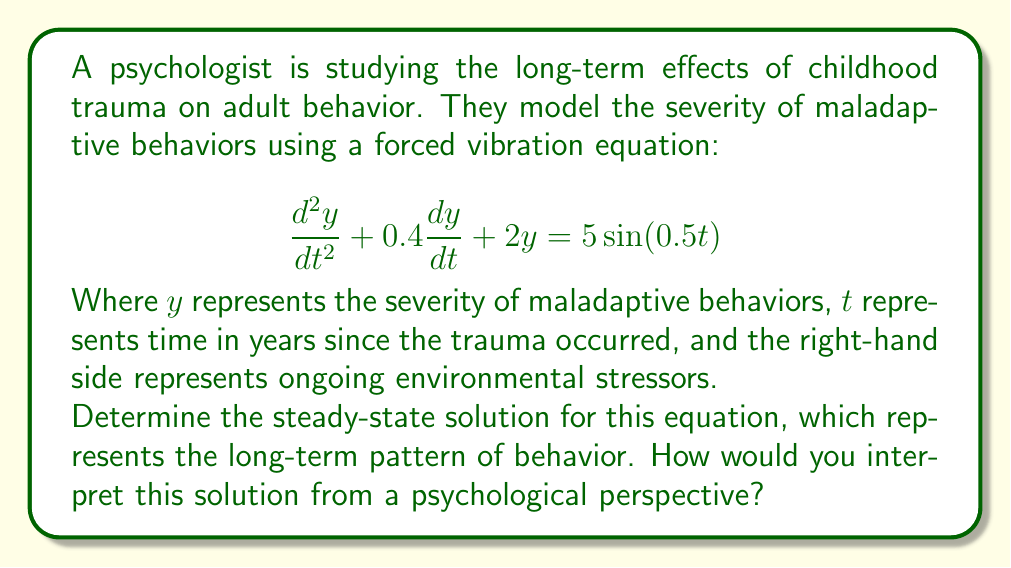Provide a solution to this math problem. To solve this problem, we follow these steps:

1) The general form of a forced vibration equation is:
   $$\frac{d^2y}{dt^2} + 2\zeta\omega_n\frac{dy}{dt} + \omega_n^2y = F_0\sin(\omega t)$$

2) Comparing our equation to this form, we can identify:
   $2\zeta\omega_n = 0.4$
   $\omega_n^2 = 2$
   $F_0 = 5$
   $\omega = 0.5$

3) The steady-state solution for a forced vibration equation has the form:
   $$y_{ss}(t) = A\sin(\omega t) + B\cos(\omega t)$$

4) The amplitudes A and B are given by:
   $$A = \frac{F_0(\omega_n^2 - \omega^2)}{(\omega_n^2 - \omega^2)^2 + (2\zeta\omega_n\omega)^2}$$
   $$B = \frac{F_0(2\zeta\omega_n\omega)}{(\omega_n^2 - \omega^2)^2 + (2\zeta\omega_n\omega)^2}$$

5) Substituting our values:
   $$A = \frac{5(2 - 0.5^2)}{(2 - 0.5^2)^2 + (0.4 \cdot 0.5)^2} \approx 2.4969$$
   $$B = \frac{5(0.4 \cdot 0.5)}{(2 - 0.5^2)^2 + (0.4 \cdot 0.5)^2} \approx 0.2497$$

6) Therefore, the steady-state solution is:
   $$y_{ss}(t) \approx 2.4969\sin(0.5t) + 0.2497\cos(0.5t)$$

From a psychological perspective, this solution suggests that the severity of maladaptive behaviors will fluctuate over time in a sinusoidal pattern. The amplitude of these fluctuations (about 2.5) indicates the range of severity. The presence of both sine and cosine terms suggests a phase shift, meaning the peak severity may not align directly with environmental stressors. The relatively small damping term (0.4) implies that these behaviors persist over time without quickly diminishing, which aligns with the understanding that childhood trauma can have long-lasting effects into adulthood.
Answer: $$y_{ss}(t) \approx 2.4969\sin(0.5t) + 0.2497\cos(0.5t)$$
This represents a persistent, cyclical pattern of maladaptive behaviors with a maximum amplitude of about 2.5, suggesting long-term effects of childhood trauma that fluctuate in severity over time. 